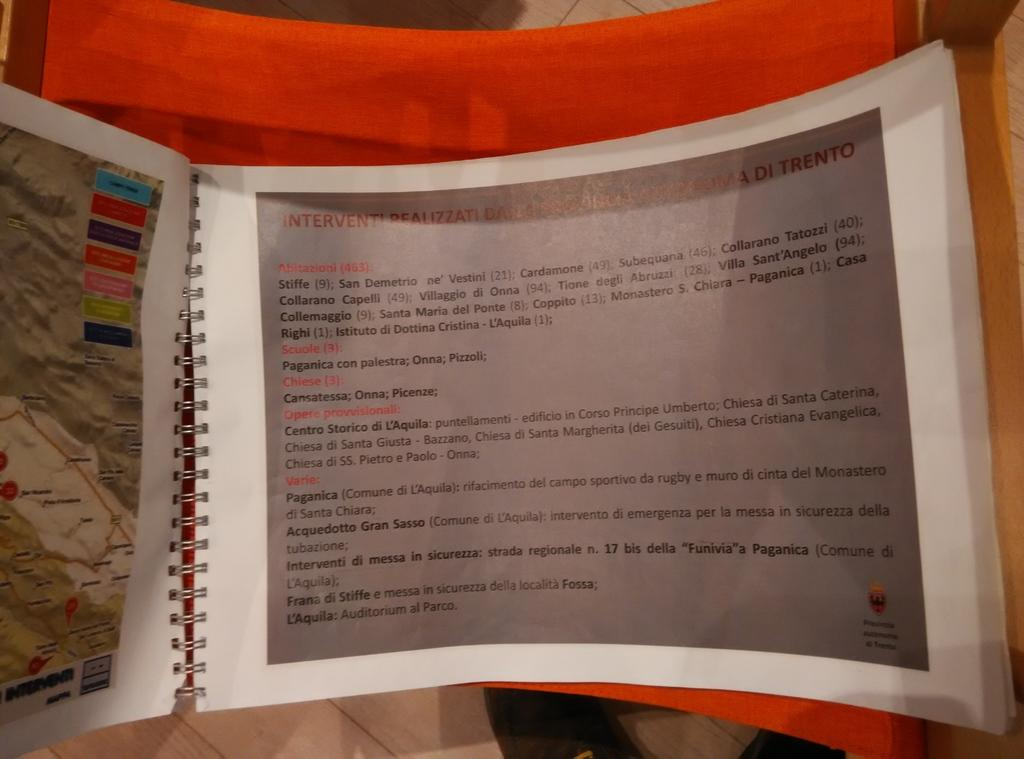<image>
Describe the image concisely. the word stiffe is on a piece of paper 